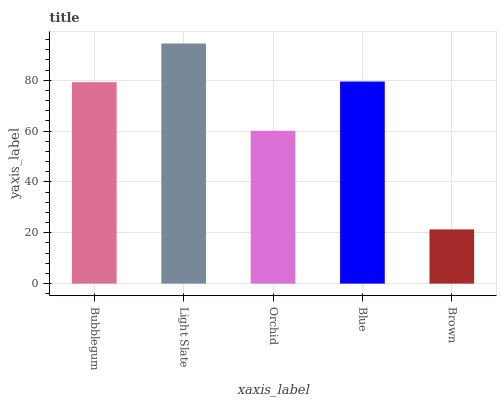Is Orchid the minimum?
Answer yes or no. No. Is Orchid the maximum?
Answer yes or no. No. Is Light Slate greater than Orchid?
Answer yes or no. Yes. Is Orchid less than Light Slate?
Answer yes or no. Yes. Is Orchid greater than Light Slate?
Answer yes or no. No. Is Light Slate less than Orchid?
Answer yes or no. No. Is Bubblegum the high median?
Answer yes or no. Yes. Is Bubblegum the low median?
Answer yes or no. Yes. Is Blue the high median?
Answer yes or no. No. Is Blue the low median?
Answer yes or no. No. 